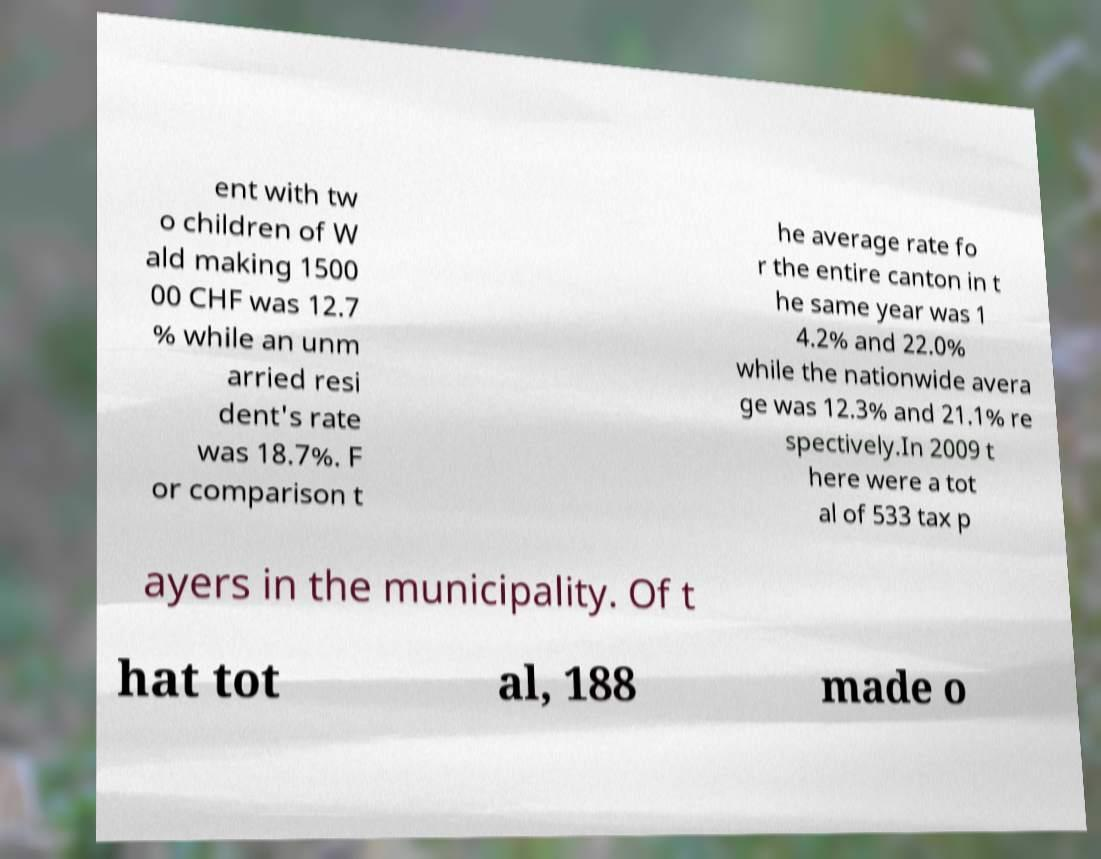Can you accurately transcribe the text from the provided image for me? ent with tw o children of W ald making 1500 00 CHF was 12.7 % while an unm arried resi dent's rate was 18.7%. F or comparison t he average rate fo r the entire canton in t he same year was 1 4.2% and 22.0% while the nationwide avera ge was 12.3% and 21.1% re spectively.In 2009 t here were a tot al of 533 tax p ayers in the municipality. Of t hat tot al, 188 made o 